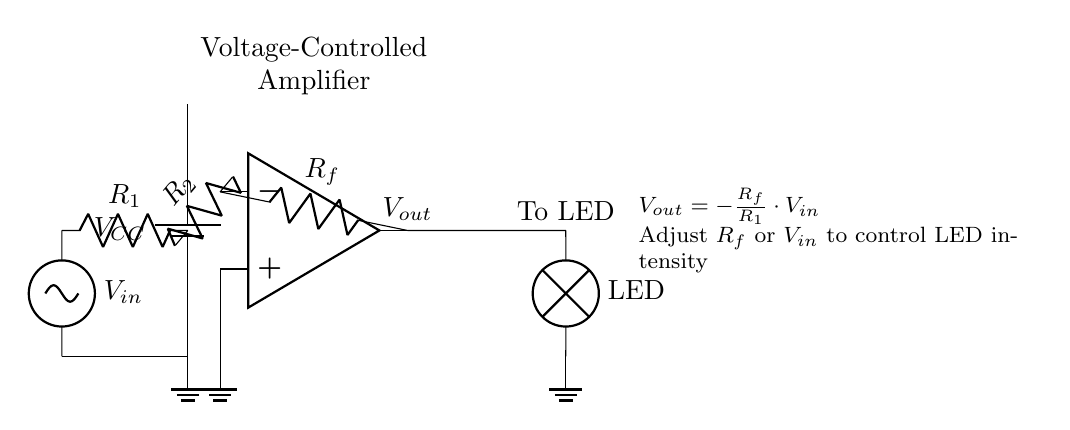What is the output voltage equation in this circuit? The output voltage equation is given as Vout = -Rf/R1 * Vin. This equation captures how the output voltage is determined based on the feedback resistor Rf, input resistor R1, and input voltage Vin.
Answer: Vout = -Rf/R1 * Vin What is the purpose of the operational amplifier in this circuit? The operational amplifier serves to amplify the input voltage signal, allowing for control over the output voltage that drives the LED. It ensures that small changes in Vin lead to larger adjustments in the output voltage, enabling precise control of the LED's brightness.
Answer: To amplify the input voltage Which component can be adjusted to control the LED intensity? The feedback resistor Rf can be adjusted, or the input voltage Vin can be varied, which will affect the overall gain of the amplifier and thus the output voltage driving the LED. This gives flexibility to control the intensity of the light emitted by the LED.
Answer: Rf or Vin What is the role of the resistors R1 and Rf in this amplifier circuit? R1 sets the input resistance, while Rf forms the feedback path that controls the gain of the amplifier. The ratio of Rf to R1 determines how much the input voltage will be amplified at the output, impacting how much the LED lights up.
Answer: Set gain and determine input resistance What type of configuration is used for this amplifier circuit? The circuit is configured as a voltage-controlled amplifier (VCA). This configuration allows the output to be modulated based on the input voltage, making it suitable for applications like controlling lighting intensity.
Answer: Voltage-controlled amplifier 